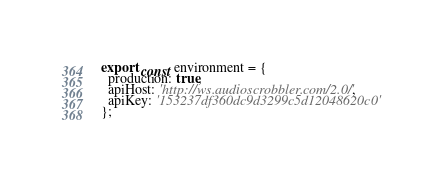Convert code to text. <code><loc_0><loc_0><loc_500><loc_500><_TypeScript_>export const environment = {
  production: true,
  apiHost: 'http://ws.audioscrobbler.com/2.0/',
  apiKey: '153237df360dc9d3299c5d12048620c0'
};
</code> 